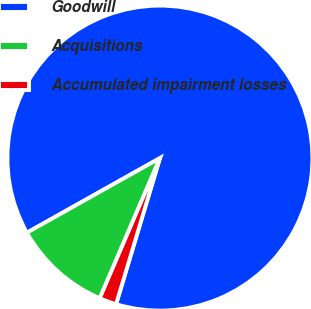<chart> <loc_0><loc_0><loc_500><loc_500><pie_chart><fcel>Goodwill<fcel>Acquisitions<fcel>Accumulated impairment losses<nl><fcel>87.77%<fcel>10.41%<fcel>1.81%<nl></chart> 